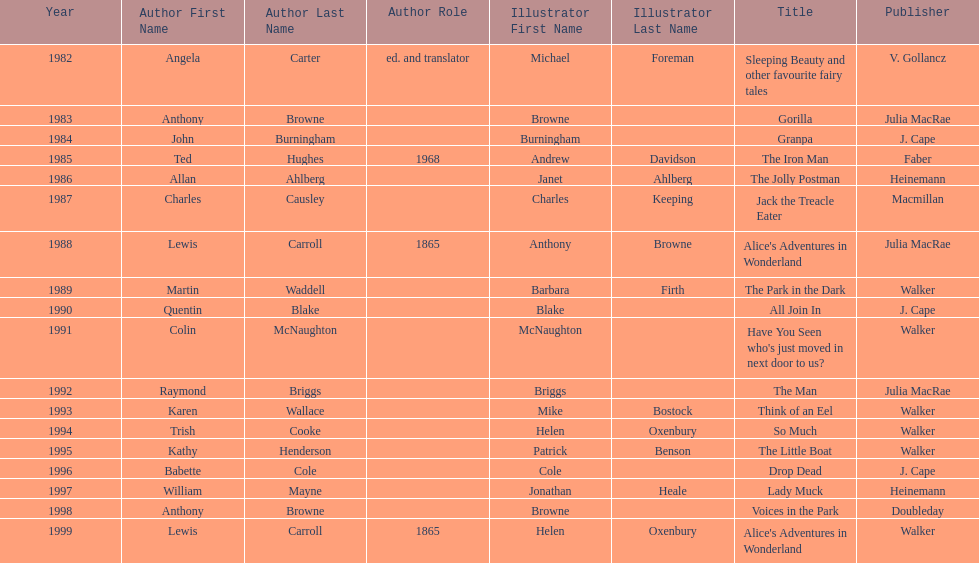What is the only title listed for 1999? Alice's Adventures in Wonderland. 